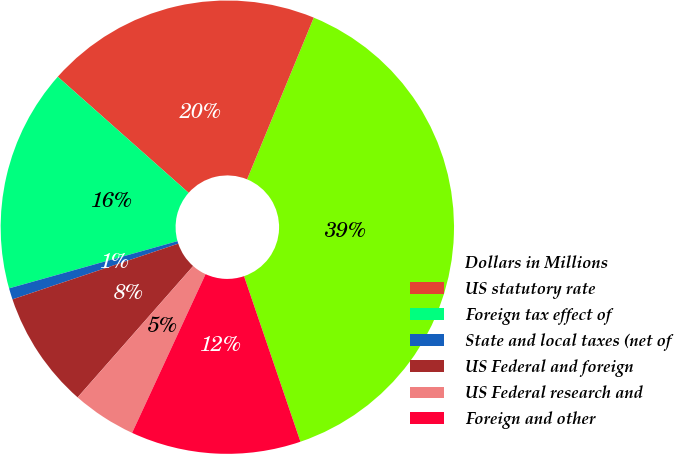<chart> <loc_0><loc_0><loc_500><loc_500><pie_chart><fcel>Dollars in Millions<fcel>US statutory rate<fcel>Foreign tax effect of<fcel>State and local taxes (net of<fcel>US Federal and foreign<fcel>US Federal research and<fcel>Foreign and other<nl><fcel>38.55%<fcel>19.68%<fcel>15.9%<fcel>0.81%<fcel>8.36%<fcel>4.58%<fcel>12.13%<nl></chart> 